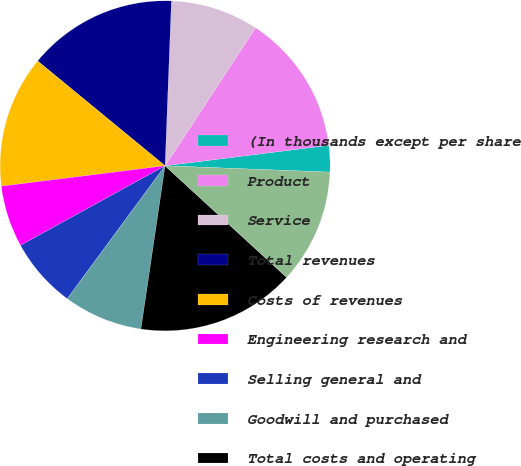<chart> <loc_0><loc_0><loc_500><loc_500><pie_chart><fcel>(In thousands except per share<fcel>Product<fcel>Service<fcel>Total revenues<fcel>Costs of revenues<fcel>Engineering research and<fcel>Selling general and<fcel>Goodwill and purchased<fcel>Total costs and operating<fcel>Income (loss) from operations<nl><fcel>2.59%<fcel>13.79%<fcel>8.62%<fcel>14.66%<fcel>12.93%<fcel>6.03%<fcel>6.9%<fcel>7.76%<fcel>15.52%<fcel>11.21%<nl></chart> 